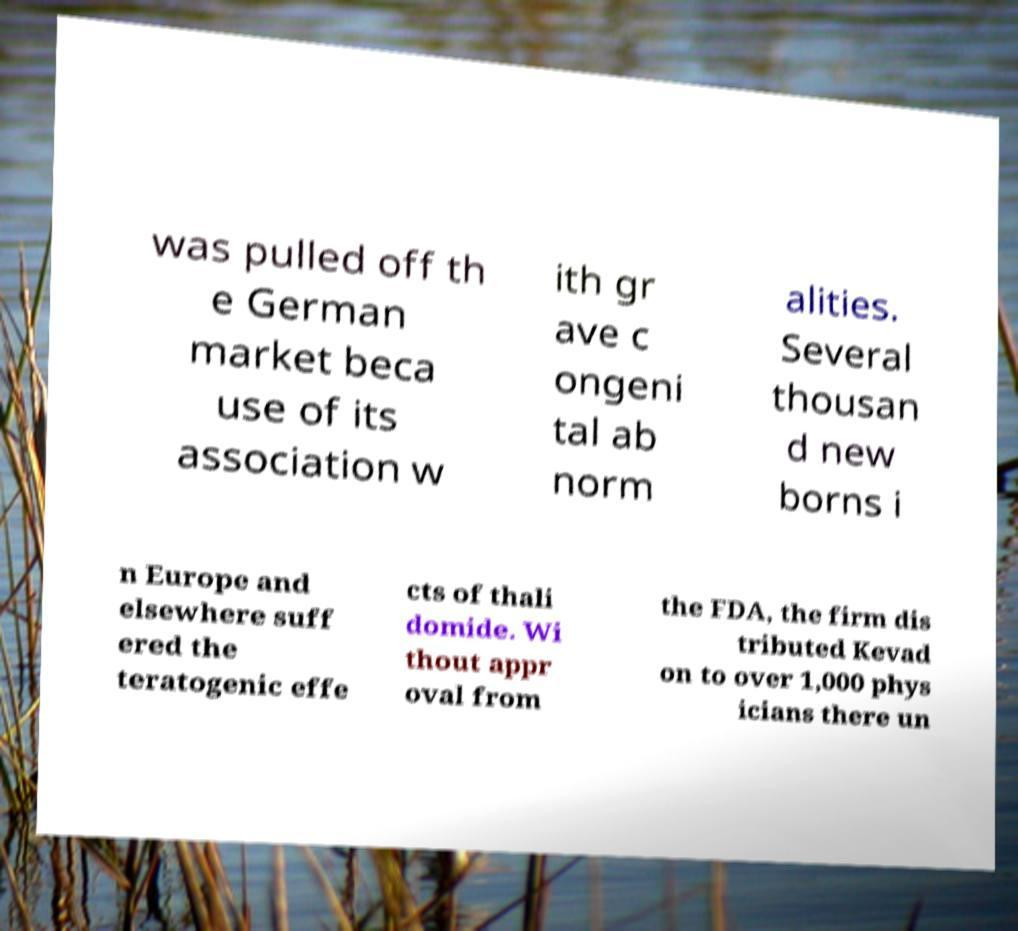I need the written content from this picture converted into text. Can you do that? was pulled off th e German market beca use of its association w ith gr ave c ongeni tal ab norm alities. Several thousan d new borns i n Europe and elsewhere suff ered the teratogenic effe cts of thali domide. Wi thout appr oval from the FDA, the firm dis tributed Kevad on to over 1,000 phys icians there un 